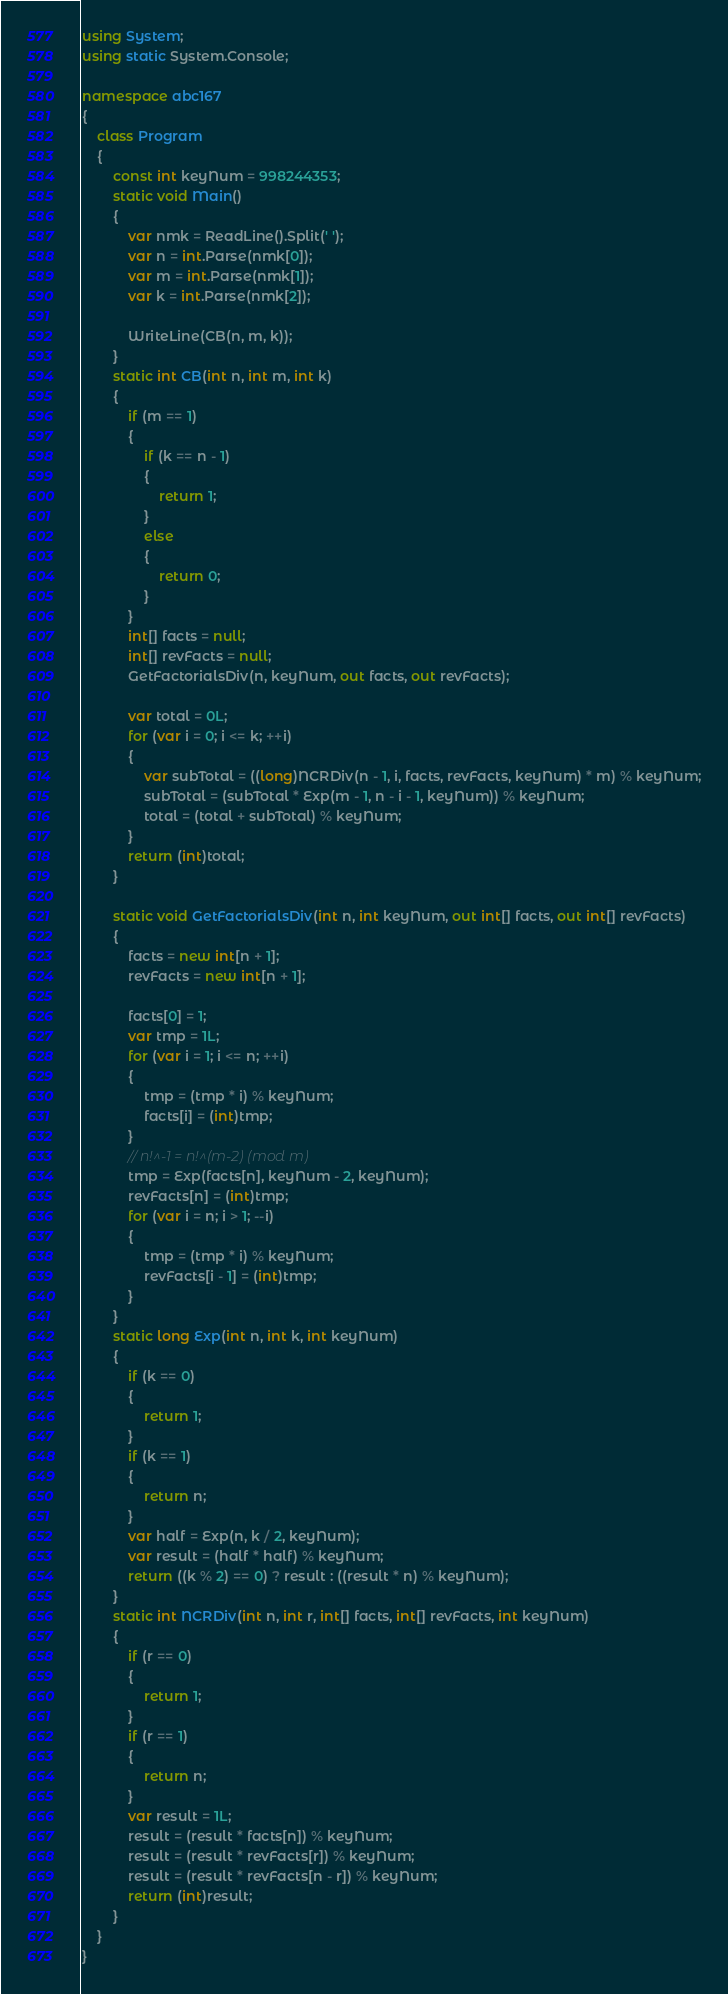Convert code to text. <code><loc_0><loc_0><loc_500><loc_500><_C#_>using System;
using static System.Console;

namespace abc167
{
    class Program
    {
        const int keyNum = 998244353;
        static void Main()
        {
            var nmk = ReadLine().Split(' ');
            var n = int.Parse(nmk[0]);
            var m = int.Parse(nmk[1]);
            var k = int.Parse(nmk[2]);

            WriteLine(CB(n, m, k));
        }
        static int CB(int n, int m, int k)
        {
            if (m == 1)
            {
                if (k == n - 1)
                {
                    return 1;
                }
                else
                {
                    return 0;
                }
            }
            int[] facts = null;
            int[] revFacts = null;
            GetFactorialsDiv(n, keyNum, out facts, out revFacts);

            var total = 0L;
            for (var i = 0; i <= k; ++i)
            {
                var subTotal = ((long)NCRDiv(n - 1, i, facts, revFacts, keyNum) * m) % keyNum;
                subTotal = (subTotal * Exp(m - 1, n - i - 1, keyNum)) % keyNum;
                total = (total + subTotal) % keyNum;
            }
            return (int)total;
        }

        static void GetFactorialsDiv(int n, int keyNum, out int[] facts, out int[] revFacts)
        {
            facts = new int[n + 1];
            revFacts = new int[n + 1];

            facts[0] = 1;
            var tmp = 1L;
            for (var i = 1; i <= n; ++i)
            {
                tmp = (tmp * i) % keyNum;
                facts[i] = (int)tmp;
            }
            // n!^-1 = n!^(m-2) (mod m)
            tmp = Exp(facts[n], keyNum - 2, keyNum);
            revFacts[n] = (int)tmp;
            for (var i = n; i > 1; --i)
            {
                tmp = (tmp * i) % keyNum;
                revFacts[i - 1] = (int)tmp;
            }
        }
        static long Exp(int n, int k, int keyNum)
        {
            if (k == 0)
            {
                return 1;
            }
            if (k == 1)
            {
                return n;
            }
            var half = Exp(n, k / 2, keyNum);
            var result = (half * half) % keyNum;
            return ((k % 2) == 0) ? result : ((result * n) % keyNum);
        }
        static int NCRDiv(int n, int r, int[] facts, int[] revFacts, int keyNum)
        {
            if (r == 0)
            {
                return 1;
            }
            if (r == 1)
            {
                return n;
            }
            var result = 1L;
            result = (result * facts[n]) % keyNum;
            result = (result * revFacts[r]) % keyNum;
            result = (result * revFacts[n - r]) % keyNum;
            return (int)result;
        }
    }
}
</code> 